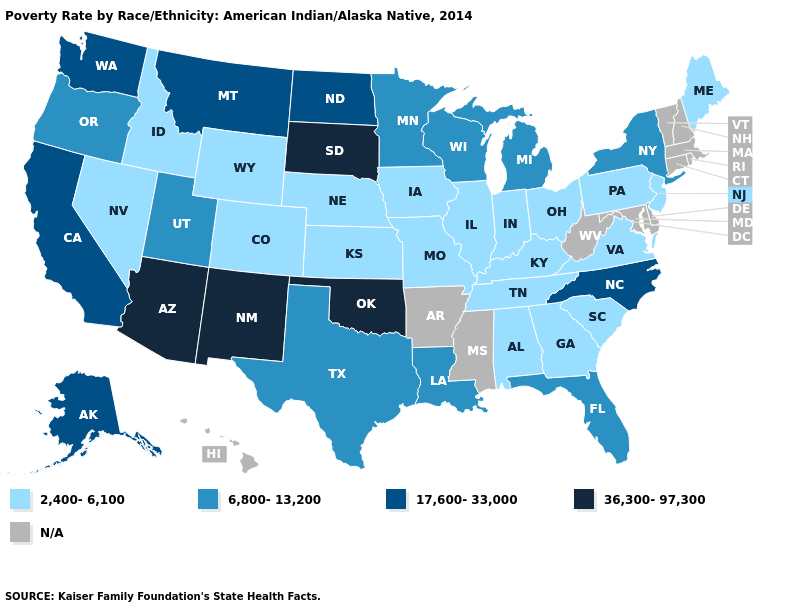What is the lowest value in states that border North Dakota?
Give a very brief answer. 6,800-13,200. Does Oklahoma have the highest value in the USA?
Be succinct. Yes. Does South Dakota have the lowest value in the MidWest?
Be succinct. No. What is the value of Maine?
Write a very short answer. 2,400-6,100. What is the value of South Dakota?
Write a very short answer. 36,300-97,300. Name the states that have a value in the range 6,800-13,200?
Give a very brief answer. Florida, Louisiana, Michigan, Minnesota, New York, Oregon, Texas, Utah, Wisconsin. What is the value of Colorado?
Concise answer only. 2,400-6,100. Among the states that border West Virginia , which have the highest value?
Concise answer only. Kentucky, Ohio, Pennsylvania, Virginia. What is the value of Arkansas?
Quick response, please. N/A. Which states have the lowest value in the USA?
Quick response, please. Alabama, Colorado, Georgia, Idaho, Illinois, Indiana, Iowa, Kansas, Kentucky, Maine, Missouri, Nebraska, Nevada, New Jersey, Ohio, Pennsylvania, South Carolina, Tennessee, Virginia, Wyoming. Is the legend a continuous bar?
Concise answer only. No. Name the states that have a value in the range 6,800-13,200?
Give a very brief answer. Florida, Louisiana, Michigan, Minnesota, New York, Oregon, Texas, Utah, Wisconsin. Name the states that have a value in the range 2,400-6,100?
Give a very brief answer. Alabama, Colorado, Georgia, Idaho, Illinois, Indiana, Iowa, Kansas, Kentucky, Maine, Missouri, Nebraska, Nevada, New Jersey, Ohio, Pennsylvania, South Carolina, Tennessee, Virginia, Wyoming. 